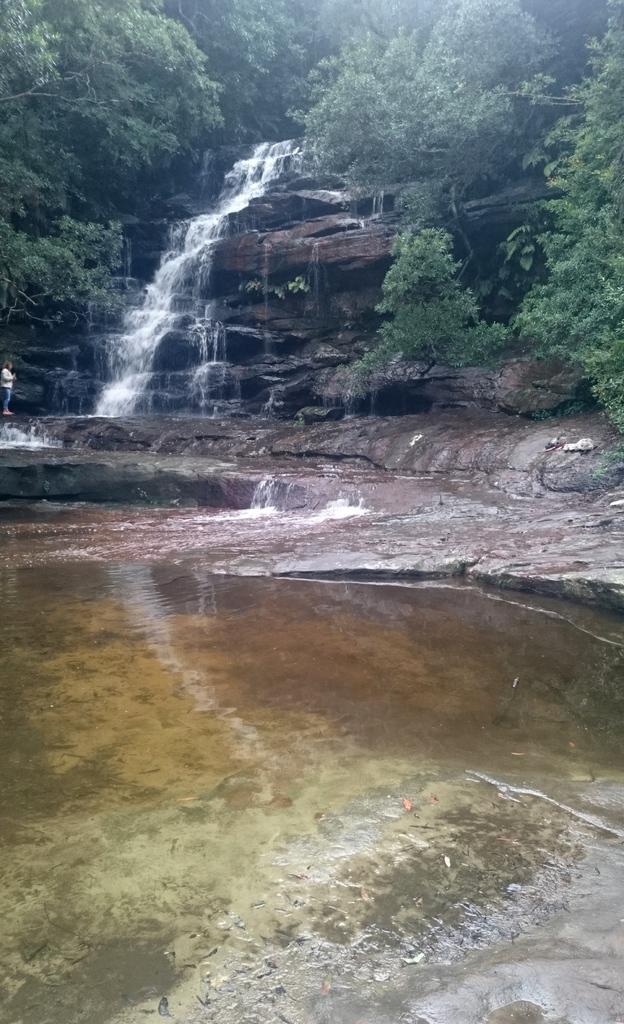How would you summarize this image in a sentence or two? In this image there is water at bottom of this image and there is a waterfall in middle of this image and there are some trees in the background of this image. 